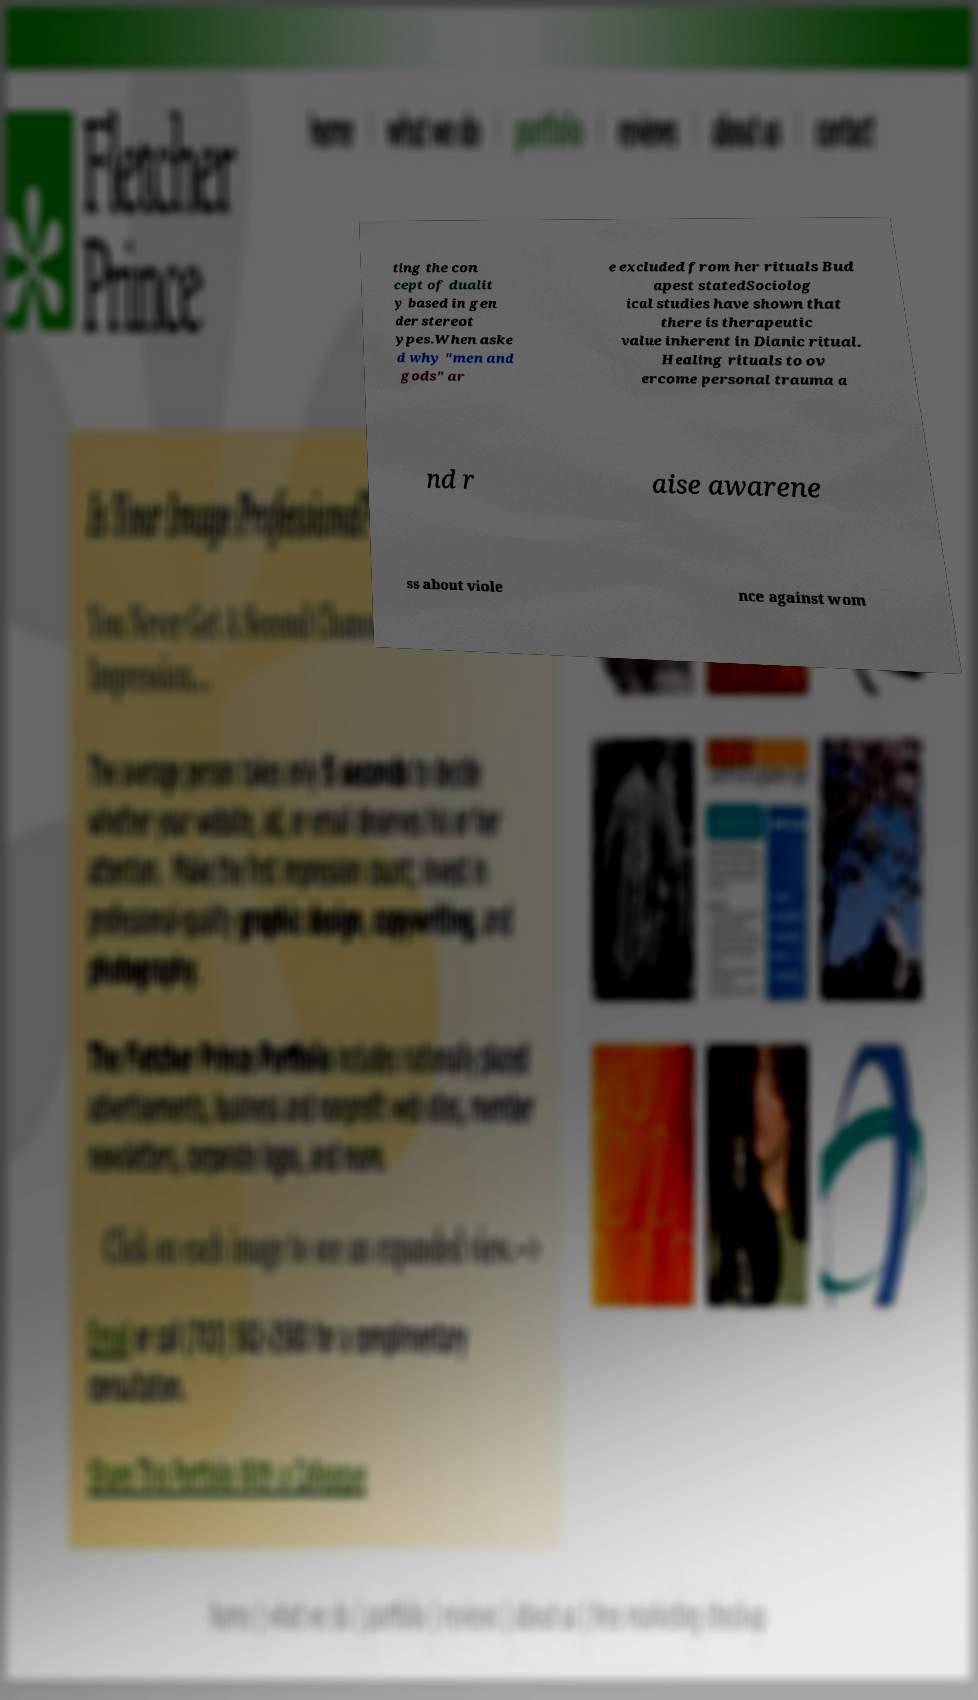There's text embedded in this image that I need extracted. Can you transcribe it verbatim? ting the con cept of dualit y based in gen der stereot ypes.When aske d why "men and gods" ar e excluded from her rituals Bud apest statedSociolog ical studies have shown that there is therapeutic value inherent in Dianic ritual. Healing rituals to ov ercome personal trauma a nd r aise awarene ss about viole nce against wom 